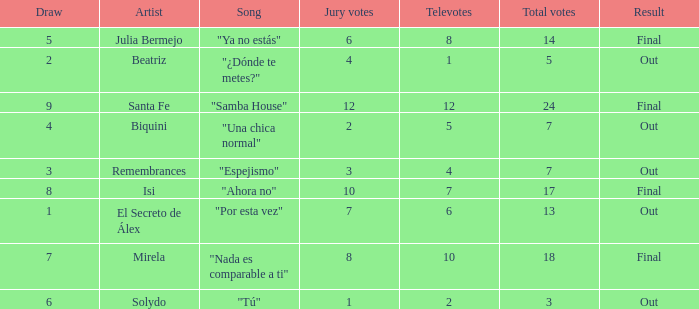Name the number of song for julia bermejo 1.0. 